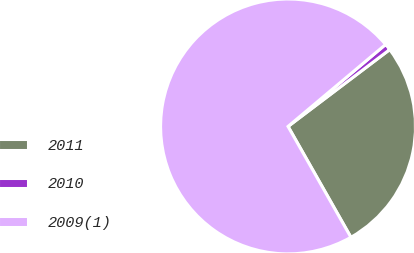Convert chart. <chart><loc_0><loc_0><loc_500><loc_500><pie_chart><fcel>2011<fcel>2010<fcel>2009(1)<nl><fcel>27.09%<fcel>0.82%<fcel>72.09%<nl></chart> 